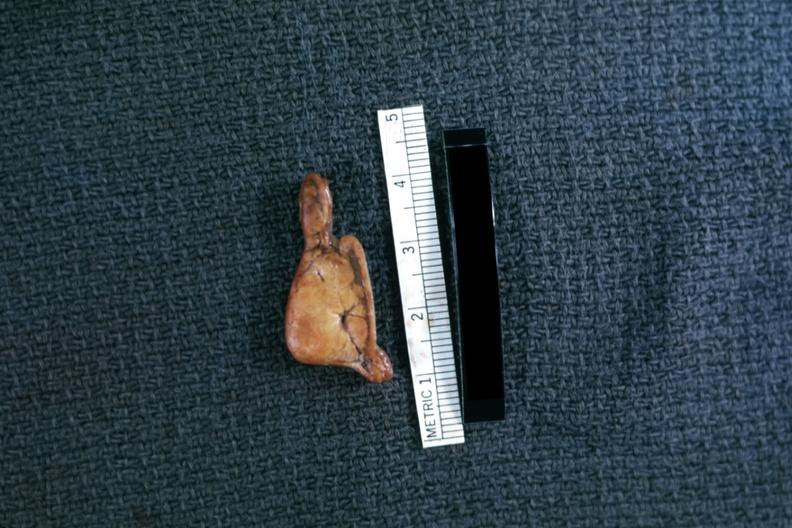s adrenal present?
Answer the question using a single word or phrase. Yes 